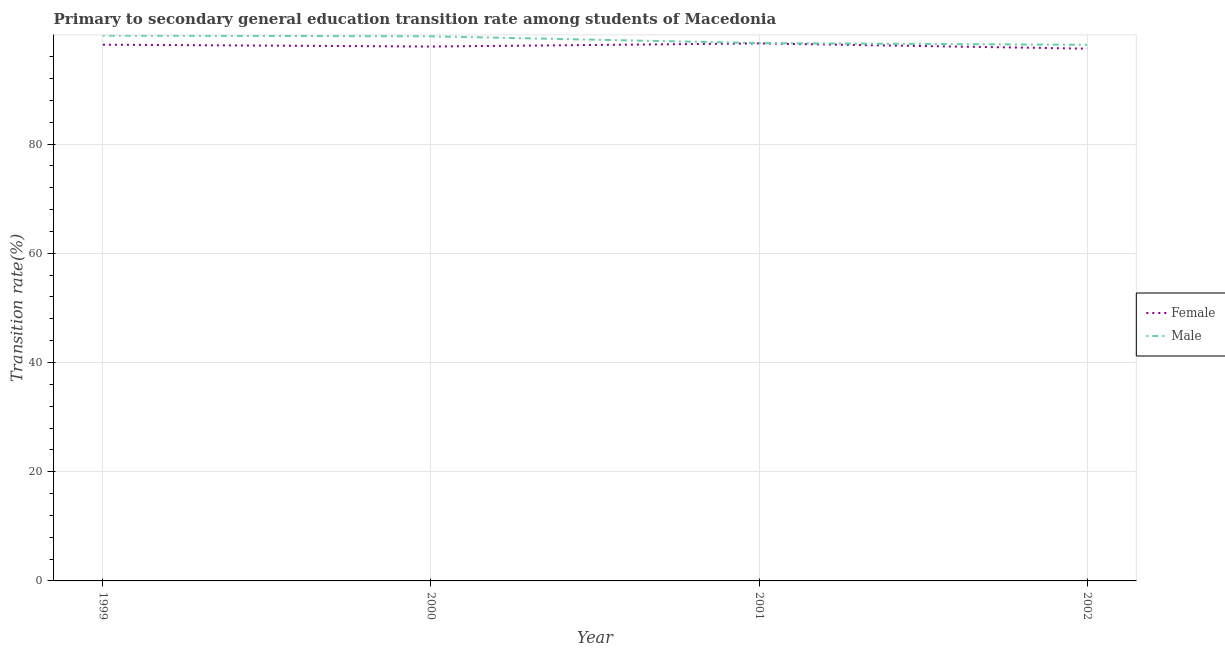How many different coloured lines are there?
Provide a short and direct response. 2. Is the number of lines equal to the number of legend labels?
Make the answer very short. Yes. What is the transition rate among male students in 2001?
Provide a succinct answer. 98.49. Across all years, what is the maximum transition rate among female students?
Your response must be concise. 98.43. Across all years, what is the minimum transition rate among female students?
Make the answer very short. 97.47. In which year was the transition rate among female students maximum?
Your answer should be compact. 2001. In which year was the transition rate among female students minimum?
Provide a short and direct response. 2002. What is the total transition rate among female students in the graph?
Offer a terse response. 391.95. What is the difference between the transition rate among female students in 2001 and that in 2002?
Offer a terse response. 0.96. What is the difference between the transition rate among male students in 2001 and the transition rate among female students in 1999?
Keep it short and to the point. 0.3. What is the average transition rate among male students per year?
Your answer should be compact. 99.07. In the year 2000, what is the difference between the transition rate among male students and transition rate among female students?
Give a very brief answer. 1.87. What is the ratio of the transition rate among male students in 1999 to that in 2002?
Your answer should be compact. 1.02. Is the transition rate among female students in 2000 less than that in 2002?
Give a very brief answer. No. Is the difference between the transition rate among female students in 1999 and 2000 greater than the difference between the transition rate among male students in 1999 and 2000?
Ensure brevity in your answer.  Yes. What is the difference between the highest and the second highest transition rate among female students?
Offer a very short reply. 0.23. What is the difference between the highest and the lowest transition rate among male students?
Your answer should be compact. 1.7. In how many years, is the transition rate among male students greater than the average transition rate among male students taken over all years?
Keep it short and to the point. 2. Is the transition rate among female students strictly less than the transition rate among male students over the years?
Provide a short and direct response. Yes. How many years are there in the graph?
Your answer should be very brief. 4. Does the graph contain any zero values?
Keep it short and to the point. No. Does the graph contain grids?
Make the answer very short. Yes. Where does the legend appear in the graph?
Ensure brevity in your answer.  Center right. How many legend labels are there?
Offer a very short reply. 2. How are the legend labels stacked?
Your answer should be compact. Vertical. What is the title of the graph?
Ensure brevity in your answer.  Primary to secondary general education transition rate among students of Macedonia. What is the label or title of the X-axis?
Offer a very short reply. Year. What is the label or title of the Y-axis?
Offer a terse response. Transition rate(%). What is the Transition rate(%) in Female in 1999?
Your answer should be compact. 98.2. What is the Transition rate(%) of Male in 1999?
Your answer should be very brief. 99.87. What is the Transition rate(%) in Female in 2000?
Make the answer very short. 97.86. What is the Transition rate(%) in Male in 2000?
Keep it short and to the point. 99.73. What is the Transition rate(%) in Female in 2001?
Your answer should be very brief. 98.43. What is the Transition rate(%) in Male in 2001?
Provide a short and direct response. 98.49. What is the Transition rate(%) in Female in 2002?
Give a very brief answer. 97.47. What is the Transition rate(%) of Male in 2002?
Your response must be concise. 98.17. Across all years, what is the maximum Transition rate(%) in Female?
Your answer should be very brief. 98.43. Across all years, what is the maximum Transition rate(%) in Male?
Make the answer very short. 99.87. Across all years, what is the minimum Transition rate(%) of Female?
Ensure brevity in your answer.  97.47. Across all years, what is the minimum Transition rate(%) in Male?
Give a very brief answer. 98.17. What is the total Transition rate(%) in Female in the graph?
Provide a succinct answer. 391.95. What is the total Transition rate(%) in Male in the graph?
Offer a very short reply. 396.26. What is the difference between the Transition rate(%) of Female in 1999 and that in 2000?
Your answer should be very brief. 0.34. What is the difference between the Transition rate(%) in Male in 1999 and that in 2000?
Offer a terse response. 0.15. What is the difference between the Transition rate(%) in Female in 1999 and that in 2001?
Keep it short and to the point. -0.23. What is the difference between the Transition rate(%) in Male in 1999 and that in 2001?
Offer a very short reply. 1.38. What is the difference between the Transition rate(%) in Female in 1999 and that in 2002?
Offer a very short reply. 0.73. What is the difference between the Transition rate(%) of Male in 1999 and that in 2002?
Provide a short and direct response. 1.7. What is the difference between the Transition rate(%) of Female in 2000 and that in 2001?
Provide a succinct answer. -0.57. What is the difference between the Transition rate(%) of Male in 2000 and that in 2001?
Provide a succinct answer. 1.24. What is the difference between the Transition rate(%) in Female in 2000 and that in 2002?
Provide a succinct answer. 0.39. What is the difference between the Transition rate(%) of Male in 2000 and that in 2002?
Your answer should be compact. 1.56. What is the difference between the Transition rate(%) of Female in 2001 and that in 2002?
Your answer should be compact. 0.96. What is the difference between the Transition rate(%) in Male in 2001 and that in 2002?
Your answer should be very brief. 0.32. What is the difference between the Transition rate(%) in Female in 1999 and the Transition rate(%) in Male in 2000?
Offer a terse response. -1.53. What is the difference between the Transition rate(%) of Female in 1999 and the Transition rate(%) of Male in 2001?
Give a very brief answer. -0.3. What is the difference between the Transition rate(%) in Female in 1999 and the Transition rate(%) in Male in 2002?
Offer a very short reply. 0.03. What is the difference between the Transition rate(%) of Female in 2000 and the Transition rate(%) of Male in 2001?
Provide a short and direct response. -0.63. What is the difference between the Transition rate(%) in Female in 2000 and the Transition rate(%) in Male in 2002?
Keep it short and to the point. -0.31. What is the difference between the Transition rate(%) of Female in 2001 and the Transition rate(%) of Male in 2002?
Your response must be concise. 0.26. What is the average Transition rate(%) in Female per year?
Your answer should be compact. 97.99. What is the average Transition rate(%) in Male per year?
Ensure brevity in your answer.  99.07. In the year 1999, what is the difference between the Transition rate(%) in Female and Transition rate(%) in Male?
Give a very brief answer. -1.68. In the year 2000, what is the difference between the Transition rate(%) of Female and Transition rate(%) of Male?
Your response must be concise. -1.87. In the year 2001, what is the difference between the Transition rate(%) of Female and Transition rate(%) of Male?
Ensure brevity in your answer.  -0.06. In the year 2002, what is the difference between the Transition rate(%) of Female and Transition rate(%) of Male?
Your response must be concise. -0.7. What is the ratio of the Transition rate(%) in Female in 1999 to that in 2000?
Offer a terse response. 1. What is the ratio of the Transition rate(%) of Female in 1999 to that in 2001?
Keep it short and to the point. 1. What is the ratio of the Transition rate(%) in Female in 1999 to that in 2002?
Provide a succinct answer. 1.01. What is the ratio of the Transition rate(%) in Male in 1999 to that in 2002?
Offer a terse response. 1.02. What is the ratio of the Transition rate(%) of Female in 2000 to that in 2001?
Your answer should be very brief. 0.99. What is the ratio of the Transition rate(%) of Male in 2000 to that in 2001?
Offer a terse response. 1.01. What is the ratio of the Transition rate(%) of Male in 2000 to that in 2002?
Offer a terse response. 1.02. What is the ratio of the Transition rate(%) in Female in 2001 to that in 2002?
Provide a succinct answer. 1.01. What is the ratio of the Transition rate(%) of Male in 2001 to that in 2002?
Your answer should be very brief. 1. What is the difference between the highest and the second highest Transition rate(%) in Female?
Your response must be concise. 0.23. What is the difference between the highest and the second highest Transition rate(%) of Male?
Provide a succinct answer. 0.15. What is the difference between the highest and the lowest Transition rate(%) of Female?
Offer a terse response. 0.96. What is the difference between the highest and the lowest Transition rate(%) of Male?
Offer a very short reply. 1.7. 